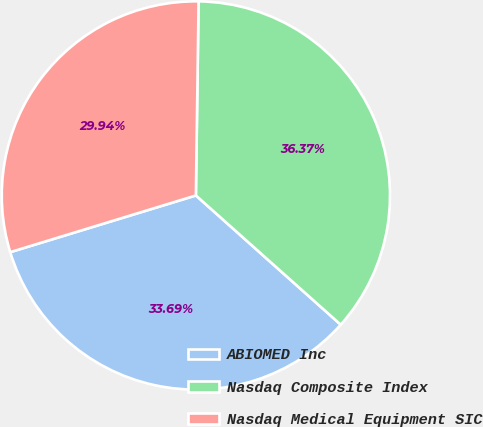<chart> <loc_0><loc_0><loc_500><loc_500><pie_chart><fcel>ABIOMED Inc<fcel>Nasdaq Composite Index<fcel>Nasdaq Medical Equipment SIC<nl><fcel>33.69%<fcel>36.37%<fcel>29.94%<nl></chart> 